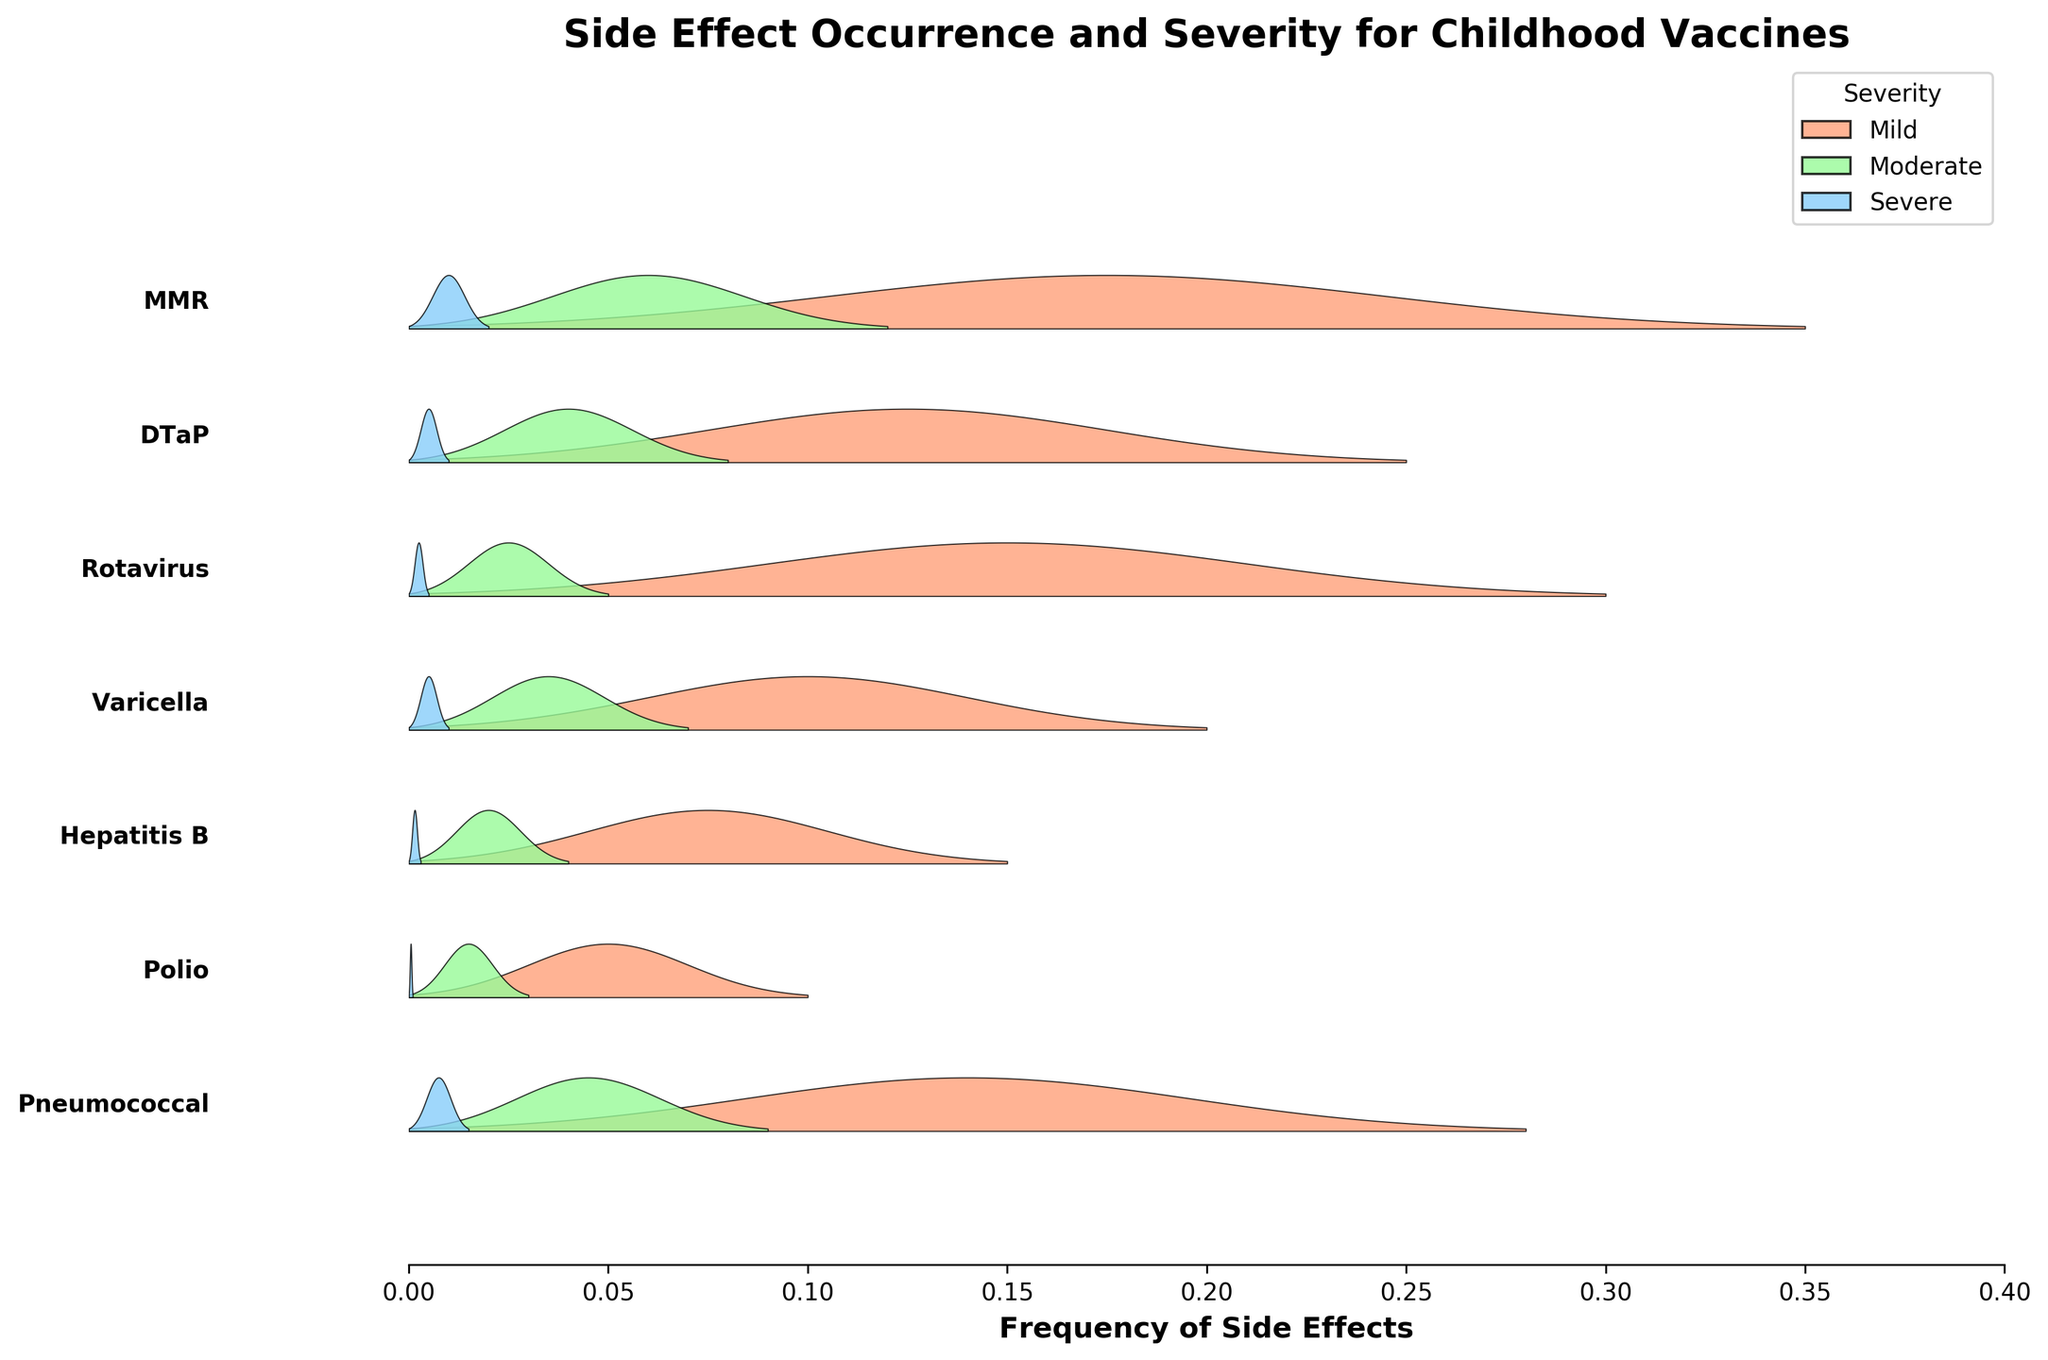Which vaccine has the highest frequency of mild side effects? To determine which vaccine has the highest frequency of mild side effects, look for the longest filled area corresponding to the "Mild" color (light salmon) on the horizontal axis. The MMR vaccine is associated with the widest mild side effect region, extending up to 0.35.
Answer: MMR Which vaccine has the lowest frequency of severe side effects? To find the vaccine with the lowest frequency of severe side effects, identify the smallest filled area associated with the "Severe" color (light blue). The Polio vaccine has the shortest severe side effect region, ending at 0.001.
Answer: Polio How does the frequency of moderate side effects for DTaP compare to those for Varicella? Compare the lengths of the moderate side effect regions (light green) for DTaP and Varicella. The moderate side effect frequency for DTaP extends to 0.08, while for Varicella, it extends to 0.07. Therefore, DTaP has a higher frequency of moderate side effects compared to Varicella.
Answer: Greater What is the average frequency for mild side effects across all vaccines? Calculate the average by summing the frequencies of mild side effects for all vaccines and dividing by the number of vaccines. The mild frequencies are: MMR(0.35), DTaP(0.25), Rotavirus(0.30), Varicella(0.20), Hepatitis B(0.15), Polio(0.10), Pneumococcal(0.28). Sum these to get 1.63 and divide by 7 vaccines, resulting in 1.63/7 ≈ 0.233.
Answer: 0.233 Which vaccine exhibits the greatest disparity between mild and severe side effects? To determine which vaccine has the greatest difference between mild and severe side effects, compute the absolute difference for each vaccine: MMR(0.35-0.02=0.33), DTaP(0.25-0.01=0.24), Rotavirus(0.30-0.005=0.295), Varicella(0.20-0.01=0.19), Hepatitis B(0.15-0.003=0.147), Polio(0.10-0.001=0.099), Pneumococcal(0.28-0.015=0.265). MMR has the largest disparity of 0.33.
Answer: MMR How does the frequency of severe side effects for Pneumococcal compare to those for Rotavirus? Check the lengths of the severe side effect regions for Pneumococcal and Rotavirus. Pneumococcal's severe side effect region extends to 0.015, while Rotavirus extends to 0.005. Therefore, Pneumococcal has a higher frequency of severe side effects compared to Rotavirus.
Answer: Greater What is the combined frequency of moderate side effects for all vaccines? Sum the frequencies of moderate side effects for all vaccines: MMR(0.12), DTaP(0.08), Rotavirus(0.05), Varicella(0.07), Hepatitis B(0.04), Polio(0.03), Pneumococcal(0.09). The total is 0.12+0.08+0.05+0.07+0.04+0.03+0.09=0.38.
Answer: 0.38 